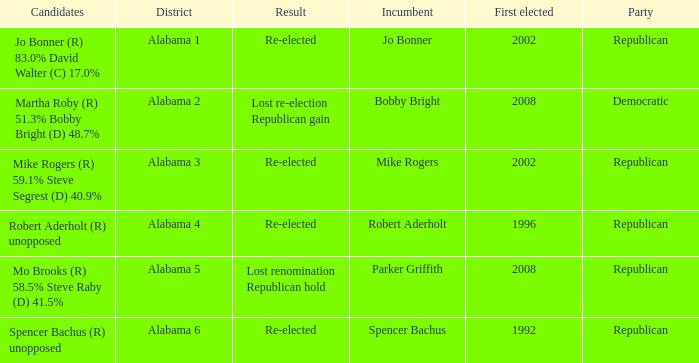Name the result for first elected being 1992 Re-elected. 